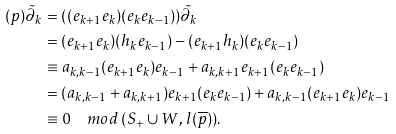Convert formula to latex. <formula><loc_0><loc_0><loc_500><loc_500>( p ) \tilde { \partial } _ { k } & = ( ( e _ { k + 1 } e _ { k } ) ( e _ { k } e _ { k - 1 } ) ) \tilde { \partial } _ { k } \\ & = ( e _ { k + 1 } e _ { k } ) ( h _ { k } e _ { k - 1 } ) - ( e _ { k + 1 } h _ { k } ) ( e _ { k } e _ { k - 1 } ) \\ & \equiv a _ { k , k - 1 } ( e _ { k + 1 } e _ { k } ) e _ { k - 1 } + a _ { k , k + 1 } e _ { k + 1 } ( e _ { k } e _ { k - 1 } ) \\ & = ( a _ { k , k - 1 } + a _ { k , k + 1 } ) e _ { k + 1 } ( e _ { k } e _ { k - 1 } ) + a _ { k , k - 1 } ( e _ { k + 1 } e _ { k } ) e _ { k - 1 } \\ & \equiv 0 \quad m o d \, ( S _ { + } \cup W , \, l ( \overline { p } ) ) .</formula> 